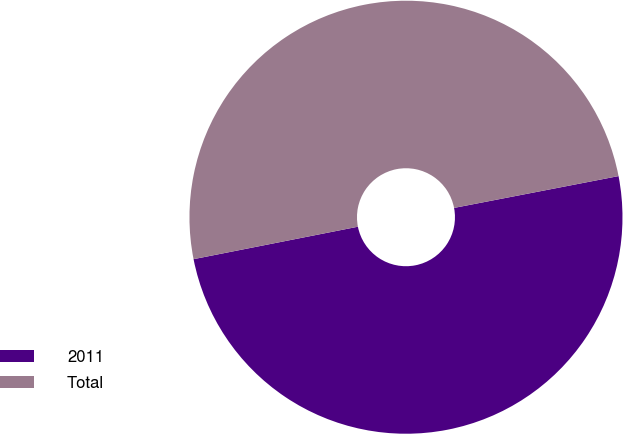Convert chart to OTSL. <chart><loc_0><loc_0><loc_500><loc_500><pie_chart><fcel>2011<fcel>Total<nl><fcel>49.94%<fcel>50.06%<nl></chart> 